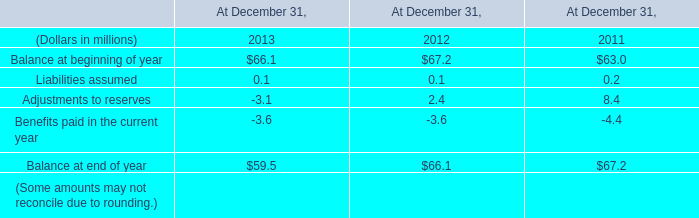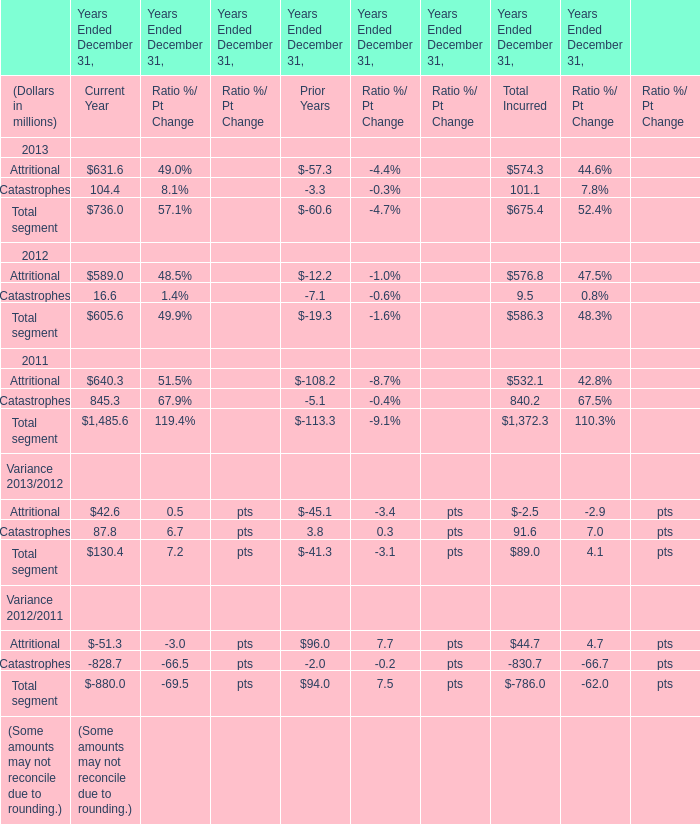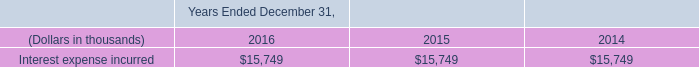What is the average value of Total segment in Current Year and Balance at beginning of year in 2013? (in million) 
Computations: ((736 + 66.1) / 2)
Answer: 401.05. 